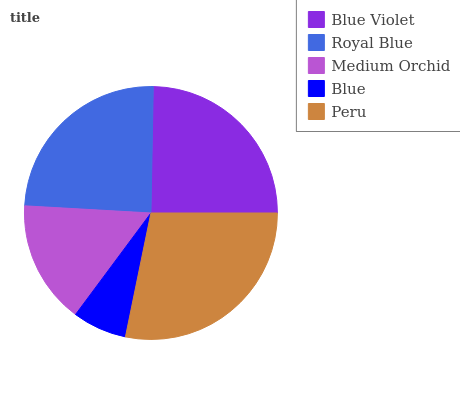Is Blue the minimum?
Answer yes or no. Yes. Is Peru the maximum?
Answer yes or no. Yes. Is Royal Blue the minimum?
Answer yes or no. No. Is Royal Blue the maximum?
Answer yes or no. No. Is Blue Violet greater than Royal Blue?
Answer yes or no. Yes. Is Royal Blue less than Blue Violet?
Answer yes or no. Yes. Is Royal Blue greater than Blue Violet?
Answer yes or no. No. Is Blue Violet less than Royal Blue?
Answer yes or no. No. Is Royal Blue the high median?
Answer yes or no. Yes. Is Royal Blue the low median?
Answer yes or no. Yes. Is Medium Orchid the high median?
Answer yes or no. No. Is Blue the low median?
Answer yes or no. No. 